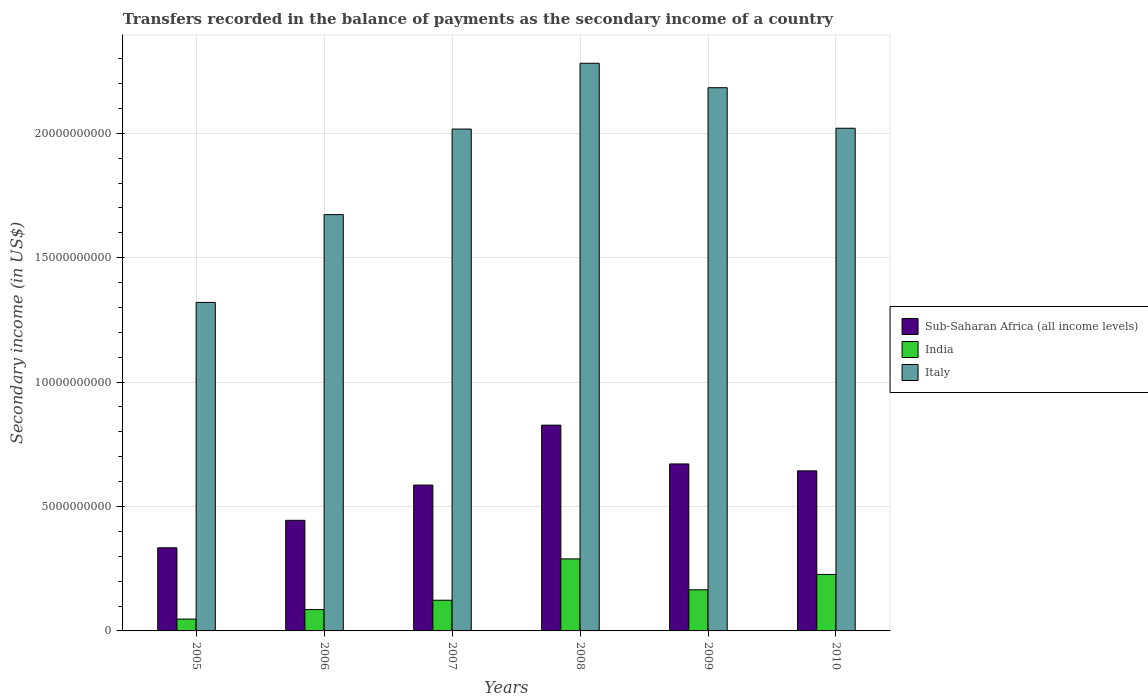How many different coloured bars are there?
Give a very brief answer. 3. What is the secondary income of in India in 2006?
Provide a succinct answer. 8.57e+08. Across all years, what is the maximum secondary income of in India?
Offer a terse response. 2.89e+09. Across all years, what is the minimum secondary income of in Sub-Saharan Africa (all income levels)?
Give a very brief answer. 3.34e+09. What is the total secondary income of in Sub-Saharan Africa (all income levels) in the graph?
Make the answer very short. 3.51e+1. What is the difference between the secondary income of in Italy in 2006 and that in 2009?
Provide a short and direct response. -5.10e+09. What is the difference between the secondary income of in Italy in 2008 and the secondary income of in India in 2006?
Your answer should be very brief. 2.20e+1. What is the average secondary income of in Sub-Saharan Africa (all income levels) per year?
Provide a short and direct response. 5.84e+09. In the year 2009, what is the difference between the secondary income of in India and secondary income of in Italy?
Provide a succinct answer. -2.02e+1. What is the ratio of the secondary income of in Italy in 2008 to that in 2010?
Make the answer very short. 1.13. Is the secondary income of in Italy in 2005 less than that in 2007?
Make the answer very short. Yes. Is the difference between the secondary income of in India in 2007 and 2009 greater than the difference between the secondary income of in Italy in 2007 and 2009?
Your answer should be compact. Yes. What is the difference between the highest and the second highest secondary income of in Sub-Saharan Africa (all income levels)?
Provide a succinct answer. 1.56e+09. What is the difference between the highest and the lowest secondary income of in Sub-Saharan Africa (all income levels)?
Offer a terse response. 4.93e+09. In how many years, is the secondary income of in Italy greater than the average secondary income of in Italy taken over all years?
Make the answer very short. 4. Is the sum of the secondary income of in India in 2005 and 2009 greater than the maximum secondary income of in Sub-Saharan Africa (all income levels) across all years?
Offer a terse response. No. What does the 1st bar from the left in 2005 represents?
Offer a terse response. Sub-Saharan Africa (all income levels). What does the 1st bar from the right in 2009 represents?
Your answer should be very brief. Italy. How many bars are there?
Keep it short and to the point. 18. How many years are there in the graph?
Your response must be concise. 6. Does the graph contain any zero values?
Offer a terse response. No. Does the graph contain grids?
Make the answer very short. Yes. How many legend labels are there?
Your response must be concise. 3. What is the title of the graph?
Provide a short and direct response. Transfers recorded in the balance of payments as the secondary income of a country. What is the label or title of the X-axis?
Your response must be concise. Years. What is the label or title of the Y-axis?
Provide a short and direct response. Secondary income (in US$). What is the Secondary income (in US$) of Sub-Saharan Africa (all income levels) in 2005?
Make the answer very short. 3.34e+09. What is the Secondary income (in US$) of India in 2005?
Offer a terse response. 4.76e+08. What is the Secondary income (in US$) of Italy in 2005?
Keep it short and to the point. 1.32e+1. What is the Secondary income (in US$) in Sub-Saharan Africa (all income levels) in 2006?
Your answer should be compact. 4.45e+09. What is the Secondary income (in US$) in India in 2006?
Make the answer very short. 8.57e+08. What is the Secondary income (in US$) in Italy in 2006?
Your response must be concise. 1.67e+1. What is the Secondary income (in US$) of Sub-Saharan Africa (all income levels) in 2007?
Keep it short and to the point. 5.86e+09. What is the Secondary income (in US$) in India in 2007?
Ensure brevity in your answer.  1.23e+09. What is the Secondary income (in US$) in Italy in 2007?
Provide a succinct answer. 2.02e+1. What is the Secondary income (in US$) of Sub-Saharan Africa (all income levels) in 2008?
Make the answer very short. 8.27e+09. What is the Secondary income (in US$) in India in 2008?
Make the answer very short. 2.89e+09. What is the Secondary income (in US$) in Italy in 2008?
Provide a short and direct response. 2.28e+1. What is the Secondary income (in US$) in Sub-Saharan Africa (all income levels) in 2009?
Ensure brevity in your answer.  6.71e+09. What is the Secondary income (in US$) in India in 2009?
Provide a short and direct response. 1.65e+09. What is the Secondary income (in US$) of Italy in 2009?
Make the answer very short. 2.18e+1. What is the Secondary income (in US$) of Sub-Saharan Africa (all income levels) in 2010?
Offer a terse response. 6.43e+09. What is the Secondary income (in US$) of India in 2010?
Offer a terse response. 2.27e+09. What is the Secondary income (in US$) of Italy in 2010?
Ensure brevity in your answer.  2.02e+1. Across all years, what is the maximum Secondary income (in US$) of Sub-Saharan Africa (all income levels)?
Offer a terse response. 8.27e+09. Across all years, what is the maximum Secondary income (in US$) of India?
Your answer should be very brief. 2.89e+09. Across all years, what is the maximum Secondary income (in US$) in Italy?
Offer a very short reply. 2.28e+1. Across all years, what is the minimum Secondary income (in US$) in Sub-Saharan Africa (all income levels)?
Make the answer very short. 3.34e+09. Across all years, what is the minimum Secondary income (in US$) in India?
Keep it short and to the point. 4.76e+08. Across all years, what is the minimum Secondary income (in US$) of Italy?
Your answer should be compact. 1.32e+1. What is the total Secondary income (in US$) in Sub-Saharan Africa (all income levels) in the graph?
Your answer should be very brief. 3.51e+1. What is the total Secondary income (in US$) of India in the graph?
Offer a very short reply. 9.38e+09. What is the total Secondary income (in US$) in Italy in the graph?
Offer a very short reply. 1.15e+11. What is the difference between the Secondary income (in US$) of Sub-Saharan Africa (all income levels) in 2005 and that in 2006?
Make the answer very short. -1.11e+09. What is the difference between the Secondary income (in US$) in India in 2005 and that in 2006?
Your answer should be compact. -3.82e+08. What is the difference between the Secondary income (in US$) of Italy in 2005 and that in 2006?
Ensure brevity in your answer.  -3.53e+09. What is the difference between the Secondary income (in US$) in Sub-Saharan Africa (all income levels) in 2005 and that in 2007?
Your response must be concise. -2.52e+09. What is the difference between the Secondary income (in US$) in India in 2005 and that in 2007?
Your response must be concise. -7.58e+08. What is the difference between the Secondary income (in US$) of Italy in 2005 and that in 2007?
Ensure brevity in your answer.  -6.97e+09. What is the difference between the Secondary income (in US$) of Sub-Saharan Africa (all income levels) in 2005 and that in 2008?
Provide a succinct answer. -4.93e+09. What is the difference between the Secondary income (in US$) of India in 2005 and that in 2008?
Your answer should be very brief. -2.42e+09. What is the difference between the Secondary income (in US$) of Italy in 2005 and that in 2008?
Your answer should be very brief. -9.61e+09. What is the difference between the Secondary income (in US$) in Sub-Saharan Africa (all income levels) in 2005 and that in 2009?
Offer a terse response. -3.37e+09. What is the difference between the Secondary income (in US$) of India in 2005 and that in 2009?
Offer a very short reply. -1.18e+09. What is the difference between the Secondary income (in US$) of Italy in 2005 and that in 2009?
Keep it short and to the point. -8.63e+09. What is the difference between the Secondary income (in US$) of Sub-Saharan Africa (all income levels) in 2005 and that in 2010?
Ensure brevity in your answer.  -3.09e+09. What is the difference between the Secondary income (in US$) in India in 2005 and that in 2010?
Your answer should be very brief. -1.79e+09. What is the difference between the Secondary income (in US$) in Italy in 2005 and that in 2010?
Your answer should be very brief. -7.00e+09. What is the difference between the Secondary income (in US$) of Sub-Saharan Africa (all income levels) in 2006 and that in 2007?
Offer a very short reply. -1.42e+09. What is the difference between the Secondary income (in US$) in India in 2006 and that in 2007?
Provide a short and direct response. -3.77e+08. What is the difference between the Secondary income (in US$) of Italy in 2006 and that in 2007?
Give a very brief answer. -3.44e+09. What is the difference between the Secondary income (in US$) of Sub-Saharan Africa (all income levels) in 2006 and that in 2008?
Give a very brief answer. -3.82e+09. What is the difference between the Secondary income (in US$) in India in 2006 and that in 2008?
Keep it short and to the point. -2.04e+09. What is the difference between the Secondary income (in US$) in Italy in 2006 and that in 2008?
Give a very brief answer. -6.08e+09. What is the difference between the Secondary income (in US$) in Sub-Saharan Africa (all income levels) in 2006 and that in 2009?
Keep it short and to the point. -2.27e+09. What is the difference between the Secondary income (in US$) of India in 2006 and that in 2009?
Offer a very short reply. -7.96e+08. What is the difference between the Secondary income (in US$) of Italy in 2006 and that in 2009?
Ensure brevity in your answer.  -5.10e+09. What is the difference between the Secondary income (in US$) in Sub-Saharan Africa (all income levels) in 2006 and that in 2010?
Your answer should be very brief. -1.99e+09. What is the difference between the Secondary income (in US$) in India in 2006 and that in 2010?
Your answer should be compact. -1.41e+09. What is the difference between the Secondary income (in US$) in Italy in 2006 and that in 2010?
Offer a terse response. -3.47e+09. What is the difference between the Secondary income (in US$) of Sub-Saharan Africa (all income levels) in 2007 and that in 2008?
Ensure brevity in your answer.  -2.41e+09. What is the difference between the Secondary income (in US$) in India in 2007 and that in 2008?
Give a very brief answer. -1.66e+09. What is the difference between the Secondary income (in US$) in Italy in 2007 and that in 2008?
Keep it short and to the point. -2.64e+09. What is the difference between the Secondary income (in US$) of Sub-Saharan Africa (all income levels) in 2007 and that in 2009?
Offer a very short reply. -8.49e+08. What is the difference between the Secondary income (in US$) in India in 2007 and that in 2009?
Your answer should be compact. -4.19e+08. What is the difference between the Secondary income (in US$) in Italy in 2007 and that in 2009?
Ensure brevity in your answer.  -1.66e+09. What is the difference between the Secondary income (in US$) of Sub-Saharan Africa (all income levels) in 2007 and that in 2010?
Your answer should be very brief. -5.71e+08. What is the difference between the Secondary income (in US$) in India in 2007 and that in 2010?
Offer a terse response. -1.04e+09. What is the difference between the Secondary income (in US$) of Italy in 2007 and that in 2010?
Provide a succinct answer. -3.25e+07. What is the difference between the Secondary income (in US$) in Sub-Saharan Africa (all income levels) in 2008 and that in 2009?
Give a very brief answer. 1.56e+09. What is the difference between the Secondary income (in US$) in India in 2008 and that in 2009?
Ensure brevity in your answer.  1.24e+09. What is the difference between the Secondary income (in US$) in Italy in 2008 and that in 2009?
Make the answer very short. 9.83e+08. What is the difference between the Secondary income (in US$) in Sub-Saharan Africa (all income levels) in 2008 and that in 2010?
Your answer should be very brief. 1.84e+09. What is the difference between the Secondary income (in US$) in India in 2008 and that in 2010?
Offer a very short reply. 6.25e+08. What is the difference between the Secondary income (in US$) of Italy in 2008 and that in 2010?
Ensure brevity in your answer.  2.61e+09. What is the difference between the Secondary income (in US$) of Sub-Saharan Africa (all income levels) in 2009 and that in 2010?
Make the answer very short. 2.78e+08. What is the difference between the Secondary income (in US$) of India in 2009 and that in 2010?
Your answer should be compact. -6.17e+08. What is the difference between the Secondary income (in US$) of Italy in 2009 and that in 2010?
Offer a very short reply. 1.63e+09. What is the difference between the Secondary income (in US$) of Sub-Saharan Africa (all income levels) in 2005 and the Secondary income (in US$) of India in 2006?
Your answer should be very brief. 2.48e+09. What is the difference between the Secondary income (in US$) in Sub-Saharan Africa (all income levels) in 2005 and the Secondary income (in US$) in Italy in 2006?
Your answer should be very brief. -1.34e+1. What is the difference between the Secondary income (in US$) in India in 2005 and the Secondary income (in US$) in Italy in 2006?
Offer a very short reply. -1.63e+1. What is the difference between the Secondary income (in US$) of Sub-Saharan Africa (all income levels) in 2005 and the Secondary income (in US$) of India in 2007?
Make the answer very short. 2.11e+09. What is the difference between the Secondary income (in US$) in Sub-Saharan Africa (all income levels) in 2005 and the Secondary income (in US$) in Italy in 2007?
Make the answer very short. -1.68e+1. What is the difference between the Secondary income (in US$) in India in 2005 and the Secondary income (in US$) in Italy in 2007?
Offer a terse response. -1.97e+1. What is the difference between the Secondary income (in US$) of Sub-Saharan Africa (all income levels) in 2005 and the Secondary income (in US$) of India in 2008?
Make the answer very short. 4.45e+08. What is the difference between the Secondary income (in US$) of Sub-Saharan Africa (all income levels) in 2005 and the Secondary income (in US$) of Italy in 2008?
Your answer should be very brief. -1.95e+1. What is the difference between the Secondary income (in US$) of India in 2005 and the Secondary income (in US$) of Italy in 2008?
Give a very brief answer. -2.23e+1. What is the difference between the Secondary income (in US$) in Sub-Saharan Africa (all income levels) in 2005 and the Secondary income (in US$) in India in 2009?
Keep it short and to the point. 1.69e+09. What is the difference between the Secondary income (in US$) in Sub-Saharan Africa (all income levels) in 2005 and the Secondary income (in US$) in Italy in 2009?
Your answer should be very brief. -1.85e+1. What is the difference between the Secondary income (in US$) in India in 2005 and the Secondary income (in US$) in Italy in 2009?
Your answer should be very brief. -2.14e+1. What is the difference between the Secondary income (in US$) of Sub-Saharan Africa (all income levels) in 2005 and the Secondary income (in US$) of India in 2010?
Offer a terse response. 1.07e+09. What is the difference between the Secondary income (in US$) in Sub-Saharan Africa (all income levels) in 2005 and the Secondary income (in US$) in Italy in 2010?
Your answer should be very brief. -1.69e+1. What is the difference between the Secondary income (in US$) in India in 2005 and the Secondary income (in US$) in Italy in 2010?
Offer a very short reply. -1.97e+1. What is the difference between the Secondary income (in US$) of Sub-Saharan Africa (all income levels) in 2006 and the Secondary income (in US$) of India in 2007?
Make the answer very short. 3.21e+09. What is the difference between the Secondary income (in US$) in Sub-Saharan Africa (all income levels) in 2006 and the Secondary income (in US$) in Italy in 2007?
Your response must be concise. -1.57e+1. What is the difference between the Secondary income (in US$) of India in 2006 and the Secondary income (in US$) of Italy in 2007?
Offer a terse response. -1.93e+1. What is the difference between the Secondary income (in US$) of Sub-Saharan Africa (all income levels) in 2006 and the Secondary income (in US$) of India in 2008?
Make the answer very short. 1.55e+09. What is the difference between the Secondary income (in US$) in Sub-Saharan Africa (all income levels) in 2006 and the Secondary income (in US$) in Italy in 2008?
Offer a very short reply. -1.84e+1. What is the difference between the Secondary income (in US$) in India in 2006 and the Secondary income (in US$) in Italy in 2008?
Make the answer very short. -2.20e+1. What is the difference between the Secondary income (in US$) of Sub-Saharan Africa (all income levels) in 2006 and the Secondary income (in US$) of India in 2009?
Make the answer very short. 2.79e+09. What is the difference between the Secondary income (in US$) of Sub-Saharan Africa (all income levels) in 2006 and the Secondary income (in US$) of Italy in 2009?
Your answer should be compact. -1.74e+1. What is the difference between the Secondary income (in US$) in India in 2006 and the Secondary income (in US$) in Italy in 2009?
Ensure brevity in your answer.  -2.10e+1. What is the difference between the Secondary income (in US$) in Sub-Saharan Africa (all income levels) in 2006 and the Secondary income (in US$) in India in 2010?
Keep it short and to the point. 2.17e+09. What is the difference between the Secondary income (in US$) in Sub-Saharan Africa (all income levels) in 2006 and the Secondary income (in US$) in Italy in 2010?
Provide a short and direct response. -1.58e+1. What is the difference between the Secondary income (in US$) in India in 2006 and the Secondary income (in US$) in Italy in 2010?
Your answer should be very brief. -1.93e+1. What is the difference between the Secondary income (in US$) in Sub-Saharan Africa (all income levels) in 2007 and the Secondary income (in US$) in India in 2008?
Give a very brief answer. 2.97e+09. What is the difference between the Secondary income (in US$) in Sub-Saharan Africa (all income levels) in 2007 and the Secondary income (in US$) in Italy in 2008?
Offer a very short reply. -1.70e+1. What is the difference between the Secondary income (in US$) in India in 2007 and the Secondary income (in US$) in Italy in 2008?
Your answer should be very brief. -2.16e+1. What is the difference between the Secondary income (in US$) in Sub-Saharan Africa (all income levels) in 2007 and the Secondary income (in US$) in India in 2009?
Ensure brevity in your answer.  4.21e+09. What is the difference between the Secondary income (in US$) in Sub-Saharan Africa (all income levels) in 2007 and the Secondary income (in US$) in Italy in 2009?
Provide a succinct answer. -1.60e+1. What is the difference between the Secondary income (in US$) in India in 2007 and the Secondary income (in US$) in Italy in 2009?
Offer a terse response. -2.06e+1. What is the difference between the Secondary income (in US$) of Sub-Saharan Africa (all income levels) in 2007 and the Secondary income (in US$) of India in 2010?
Your answer should be very brief. 3.59e+09. What is the difference between the Secondary income (in US$) of Sub-Saharan Africa (all income levels) in 2007 and the Secondary income (in US$) of Italy in 2010?
Your answer should be compact. -1.43e+1. What is the difference between the Secondary income (in US$) of India in 2007 and the Secondary income (in US$) of Italy in 2010?
Provide a succinct answer. -1.90e+1. What is the difference between the Secondary income (in US$) of Sub-Saharan Africa (all income levels) in 2008 and the Secondary income (in US$) of India in 2009?
Keep it short and to the point. 6.62e+09. What is the difference between the Secondary income (in US$) of Sub-Saharan Africa (all income levels) in 2008 and the Secondary income (in US$) of Italy in 2009?
Provide a short and direct response. -1.36e+1. What is the difference between the Secondary income (in US$) of India in 2008 and the Secondary income (in US$) of Italy in 2009?
Keep it short and to the point. -1.89e+1. What is the difference between the Secondary income (in US$) in Sub-Saharan Africa (all income levels) in 2008 and the Secondary income (in US$) in India in 2010?
Keep it short and to the point. 6.00e+09. What is the difference between the Secondary income (in US$) of Sub-Saharan Africa (all income levels) in 2008 and the Secondary income (in US$) of Italy in 2010?
Your response must be concise. -1.19e+1. What is the difference between the Secondary income (in US$) in India in 2008 and the Secondary income (in US$) in Italy in 2010?
Your response must be concise. -1.73e+1. What is the difference between the Secondary income (in US$) of Sub-Saharan Africa (all income levels) in 2009 and the Secondary income (in US$) of India in 2010?
Keep it short and to the point. 4.44e+09. What is the difference between the Secondary income (in US$) in Sub-Saharan Africa (all income levels) in 2009 and the Secondary income (in US$) in Italy in 2010?
Make the answer very short. -1.35e+1. What is the difference between the Secondary income (in US$) in India in 2009 and the Secondary income (in US$) in Italy in 2010?
Ensure brevity in your answer.  -1.85e+1. What is the average Secondary income (in US$) of Sub-Saharan Africa (all income levels) per year?
Provide a short and direct response. 5.84e+09. What is the average Secondary income (in US$) in India per year?
Your answer should be compact. 1.56e+09. What is the average Secondary income (in US$) of Italy per year?
Offer a terse response. 1.92e+1. In the year 2005, what is the difference between the Secondary income (in US$) in Sub-Saharan Africa (all income levels) and Secondary income (in US$) in India?
Your answer should be compact. 2.86e+09. In the year 2005, what is the difference between the Secondary income (in US$) in Sub-Saharan Africa (all income levels) and Secondary income (in US$) in Italy?
Provide a succinct answer. -9.86e+09. In the year 2005, what is the difference between the Secondary income (in US$) of India and Secondary income (in US$) of Italy?
Offer a terse response. -1.27e+1. In the year 2006, what is the difference between the Secondary income (in US$) of Sub-Saharan Africa (all income levels) and Secondary income (in US$) of India?
Your answer should be very brief. 3.59e+09. In the year 2006, what is the difference between the Secondary income (in US$) in Sub-Saharan Africa (all income levels) and Secondary income (in US$) in Italy?
Offer a very short reply. -1.23e+1. In the year 2006, what is the difference between the Secondary income (in US$) of India and Secondary income (in US$) of Italy?
Keep it short and to the point. -1.59e+1. In the year 2007, what is the difference between the Secondary income (in US$) in Sub-Saharan Africa (all income levels) and Secondary income (in US$) in India?
Ensure brevity in your answer.  4.63e+09. In the year 2007, what is the difference between the Secondary income (in US$) of Sub-Saharan Africa (all income levels) and Secondary income (in US$) of Italy?
Offer a very short reply. -1.43e+1. In the year 2007, what is the difference between the Secondary income (in US$) of India and Secondary income (in US$) of Italy?
Give a very brief answer. -1.89e+1. In the year 2008, what is the difference between the Secondary income (in US$) of Sub-Saharan Africa (all income levels) and Secondary income (in US$) of India?
Provide a short and direct response. 5.37e+09. In the year 2008, what is the difference between the Secondary income (in US$) of Sub-Saharan Africa (all income levels) and Secondary income (in US$) of Italy?
Provide a succinct answer. -1.45e+1. In the year 2008, what is the difference between the Secondary income (in US$) of India and Secondary income (in US$) of Italy?
Give a very brief answer. -1.99e+1. In the year 2009, what is the difference between the Secondary income (in US$) in Sub-Saharan Africa (all income levels) and Secondary income (in US$) in India?
Offer a terse response. 5.06e+09. In the year 2009, what is the difference between the Secondary income (in US$) in Sub-Saharan Africa (all income levels) and Secondary income (in US$) in Italy?
Offer a very short reply. -1.51e+1. In the year 2009, what is the difference between the Secondary income (in US$) of India and Secondary income (in US$) of Italy?
Your answer should be compact. -2.02e+1. In the year 2010, what is the difference between the Secondary income (in US$) of Sub-Saharan Africa (all income levels) and Secondary income (in US$) of India?
Your answer should be compact. 4.16e+09. In the year 2010, what is the difference between the Secondary income (in US$) in Sub-Saharan Africa (all income levels) and Secondary income (in US$) in Italy?
Provide a short and direct response. -1.38e+1. In the year 2010, what is the difference between the Secondary income (in US$) in India and Secondary income (in US$) in Italy?
Offer a terse response. -1.79e+1. What is the ratio of the Secondary income (in US$) in Sub-Saharan Africa (all income levels) in 2005 to that in 2006?
Your answer should be very brief. 0.75. What is the ratio of the Secondary income (in US$) in India in 2005 to that in 2006?
Offer a terse response. 0.55. What is the ratio of the Secondary income (in US$) of Italy in 2005 to that in 2006?
Give a very brief answer. 0.79. What is the ratio of the Secondary income (in US$) of Sub-Saharan Africa (all income levels) in 2005 to that in 2007?
Your response must be concise. 0.57. What is the ratio of the Secondary income (in US$) in India in 2005 to that in 2007?
Your answer should be compact. 0.39. What is the ratio of the Secondary income (in US$) in Italy in 2005 to that in 2007?
Ensure brevity in your answer.  0.65. What is the ratio of the Secondary income (in US$) in Sub-Saharan Africa (all income levels) in 2005 to that in 2008?
Offer a very short reply. 0.4. What is the ratio of the Secondary income (in US$) of India in 2005 to that in 2008?
Ensure brevity in your answer.  0.16. What is the ratio of the Secondary income (in US$) of Italy in 2005 to that in 2008?
Your response must be concise. 0.58. What is the ratio of the Secondary income (in US$) of Sub-Saharan Africa (all income levels) in 2005 to that in 2009?
Your response must be concise. 0.5. What is the ratio of the Secondary income (in US$) of India in 2005 to that in 2009?
Provide a succinct answer. 0.29. What is the ratio of the Secondary income (in US$) in Italy in 2005 to that in 2009?
Make the answer very short. 0.6. What is the ratio of the Secondary income (in US$) in Sub-Saharan Africa (all income levels) in 2005 to that in 2010?
Provide a short and direct response. 0.52. What is the ratio of the Secondary income (in US$) of India in 2005 to that in 2010?
Give a very brief answer. 0.21. What is the ratio of the Secondary income (in US$) of Italy in 2005 to that in 2010?
Provide a short and direct response. 0.65. What is the ratio of the Secondary income (in US$) in Sub-Saharan Africa (all income levels) in 2006 to that in 2007?
Your response must be concise. 0.76. What is the ratio of the Secondary income (in US$) of India in 2006 to that in 2007?
Your answer should be very brief. 0.69. What is the ratio of the Secondary income (in US$) of Italy in 2006 to that in 2007?
Ensure brevity in your answer.  0.83. What is the ratio of the Secondary income (in US$) in Sub-Saharan Africa (all income levels) in 2006 to that in 2008?
Keep it short and to the point. 0.54. What is the ratio of the Secondary income (in US$) of India in 2006 to that in 2008?
Your response must be concise. 0.3. What is the ratio of the Secondary income (in US$) in Italy in 2006 to that in 2008?
Keep it short and to the point. 0.73. What is the ratio of the Secondary income (in US$) in Sub-Saharan Africa (all income levels) in 2006 to that in 2009?
Your answer should be very brief. 0.66. What is the ratio of the Secondary income (in US$) of India in 2006 to that in 2009?
Keep it short and to the point. 0.52. What is the ratio of the Secondary income (in US$) in Italy in 2006 to that in 2009?
Provide a short and direct response. 0.77. What is the ratio of the Secondary income (in US$) in Sub-Saharan Africa (all income levels) in 2006 to that in 2010?
Provide a succinct answer. 0.69. What is the ratio of the Secondary income (in US$) in India in 2006 to that in 2010?
Your answer should be very brief. 0.38. What is the ratio of the Secondary income (in US$) of Italy in 2006 to that in 2010?
Give a very brief answer. 0.83. What is the ratio of the Secondary income (in US$) of Sub-Saharan Africa (all income levels) in 2007 to that in 2008?
Keep it short and to the point. 0.71. What is the ratio of the Secondary income (in US$) of India in 2007 to that in 2008?
Offer a very short reply. 0.43. What is the ratio of the Secondary income (in US$) in Italy in 2007 to that in 2008?
Your answer should be very brief. 0.88. What is the ratio of the Secondary income (in US$) in Sub-Saharan Africa (all income levels) in 2007 to that in 2009?
Give a very brief answer. 0.87. What is the ratio of the Secondary income (in US$) of India in 2007 to that in 2009?
Provide a succinct answer. 0.75. What is the ratio of the Secondary income (in US$) of Italy in 2007 to that in 2009?
Your answer should be very brief. 0.92. What is the ratio of the Secondary income (in US$) of Sub-Saharan Africa (all income levels) in 2007 to that in 2010?
Keep it short and to the point. 0.91. What is the ratio of the Secondary income (in US$) in India in 2007 to that in 2010?
Your answer should be very brief. 0.54. What is the ratio of the Secondary income (in US$) of Sub-Saharan Africa (all income levels) in 2008 to that in 2009?
Ensure brevity in your answer.  1.23. What is the ratio of the Secondary income (in US$) of India in 2008 to that in 2009?
Give a very brief answer. 1.75. What is the ratio of the Secondary income (in US$) of Italy in 2008 to that in 2009?
Provide a short and direct response. 1.04. What is the ratio of the Secondary income (in US$) in Sub-Saharan Africa (all income levels) in 2008 to that in 2010?
Give a very brief answer. 1.29. What is the ratio of the Secondary income (in US$) in India in 2008 to that in 2010?
Your answer should be compact. 1.28. What is the ratio of the Secondary income (in US$) of Italy in 2008 to that in 2010?
Offer a terse response. 1.13. What is the ratio of the Secondary income (in US$) in Sub-Saharan Africa (all income levels) in 2009 to that in 2010?
Your response must be concise. 1.04. What is the ratio of the Secondary income (in US$) in India in 2009 to that in 2010?
Give a very brief answer. 0.73. What is the ratio of the Secondary income (in US$) of Italy in 2009 to that in 2010?
Your answer should be compact. 1.08. What is the difference between the highest and the second highest Secondary income (in US$) in Sub-Saharan Africa (all income levels)?
Your answer should be very brief. 1.56e+09. What is the difference between the highest and the second highest Secondary income (in US$) in India?
Your answer should be compact. 6.25e+08. What is the difference between the highest and the second highest Secondary income (in US$) in Italy?
Offer a very short reply. 9.83e+08. What is the difference between the highest and the lowest Secondary income (in US$) in Sub-Saharan Africa (all income levels)?
Give a very brief answer. 4.93e+09. What is the difference between the highest and the lowest Secondary income (in US$) in India?
Your response must be concise. 2.42e+09. What is the difference between the highest and the lowest Secondary income (in US$) in Italy?
Offer a terse response. 9.61e+09. 